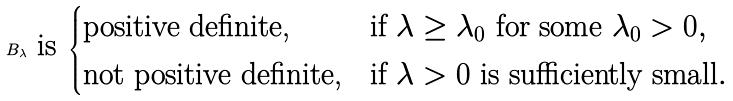<formula> <loc_0><loc_0><loc_500><loc_500>B _ { \lambda } \text { is } \begin{cases} \text {positive definite,} & \text {if $\lambda \geq \lambda_{0}$ for some $\lambda_{0} > 0$} , \\ \text {not positive definite,} & \text {if $\lambda > 0$ is sufficiently small} . \end{cases}</formula> 